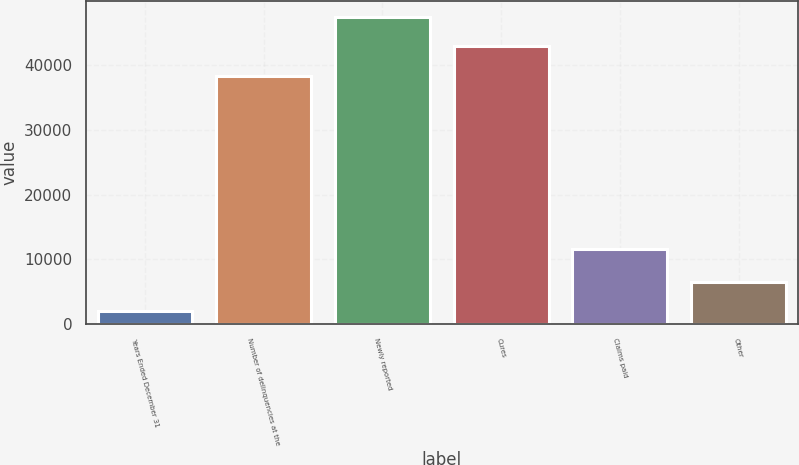Convert chart. <chart><loc_0><loc_0><loc_500><loc_500><bar_chart><fcel>Years Ended December 31<fcel>Number of delinquencies at the<fcel>Newly reported<fcel>Cures<fcel>Claims paid<fcel>Other<nl><fcel>2014<fcel>38357<fcel>47457.8<fcel>42907.4<fcel>11601<fcel>6564.4<nl></chart> 